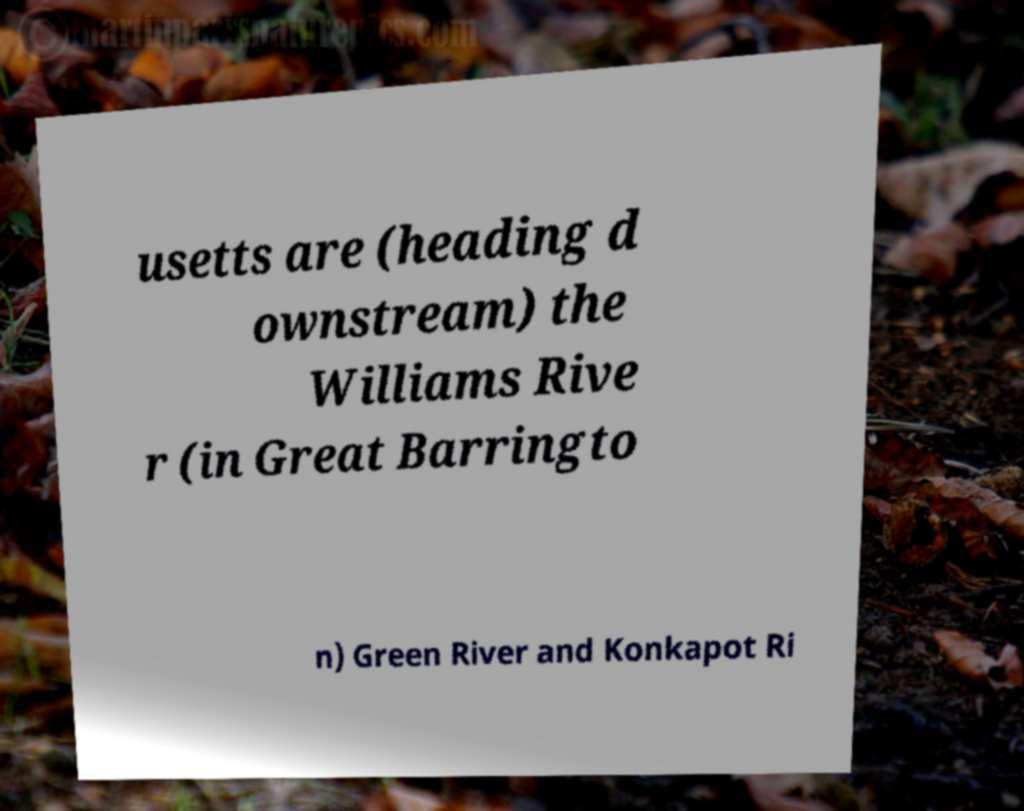What messages or text are displayed in this image? I need them in a readable, typed format. usetts are (heading d ownstream) the Williams Rive r (in Great Barringto n) Green River and Konkapot Ri 